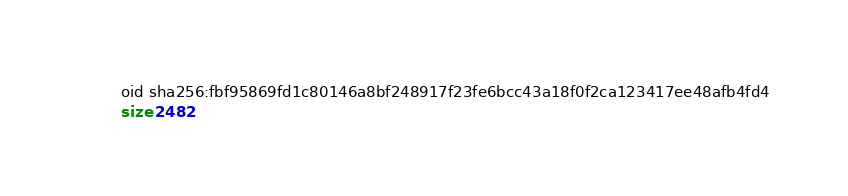Convert code to text. <code><loc_0><loc_0><loc_500><loc_500><_SQL_>oid sha256:fbf95869fd1c80146a8bf248917f23fe6bcc43a18f0f2ca123417ee48afb4fd4
size 2482
</code> 